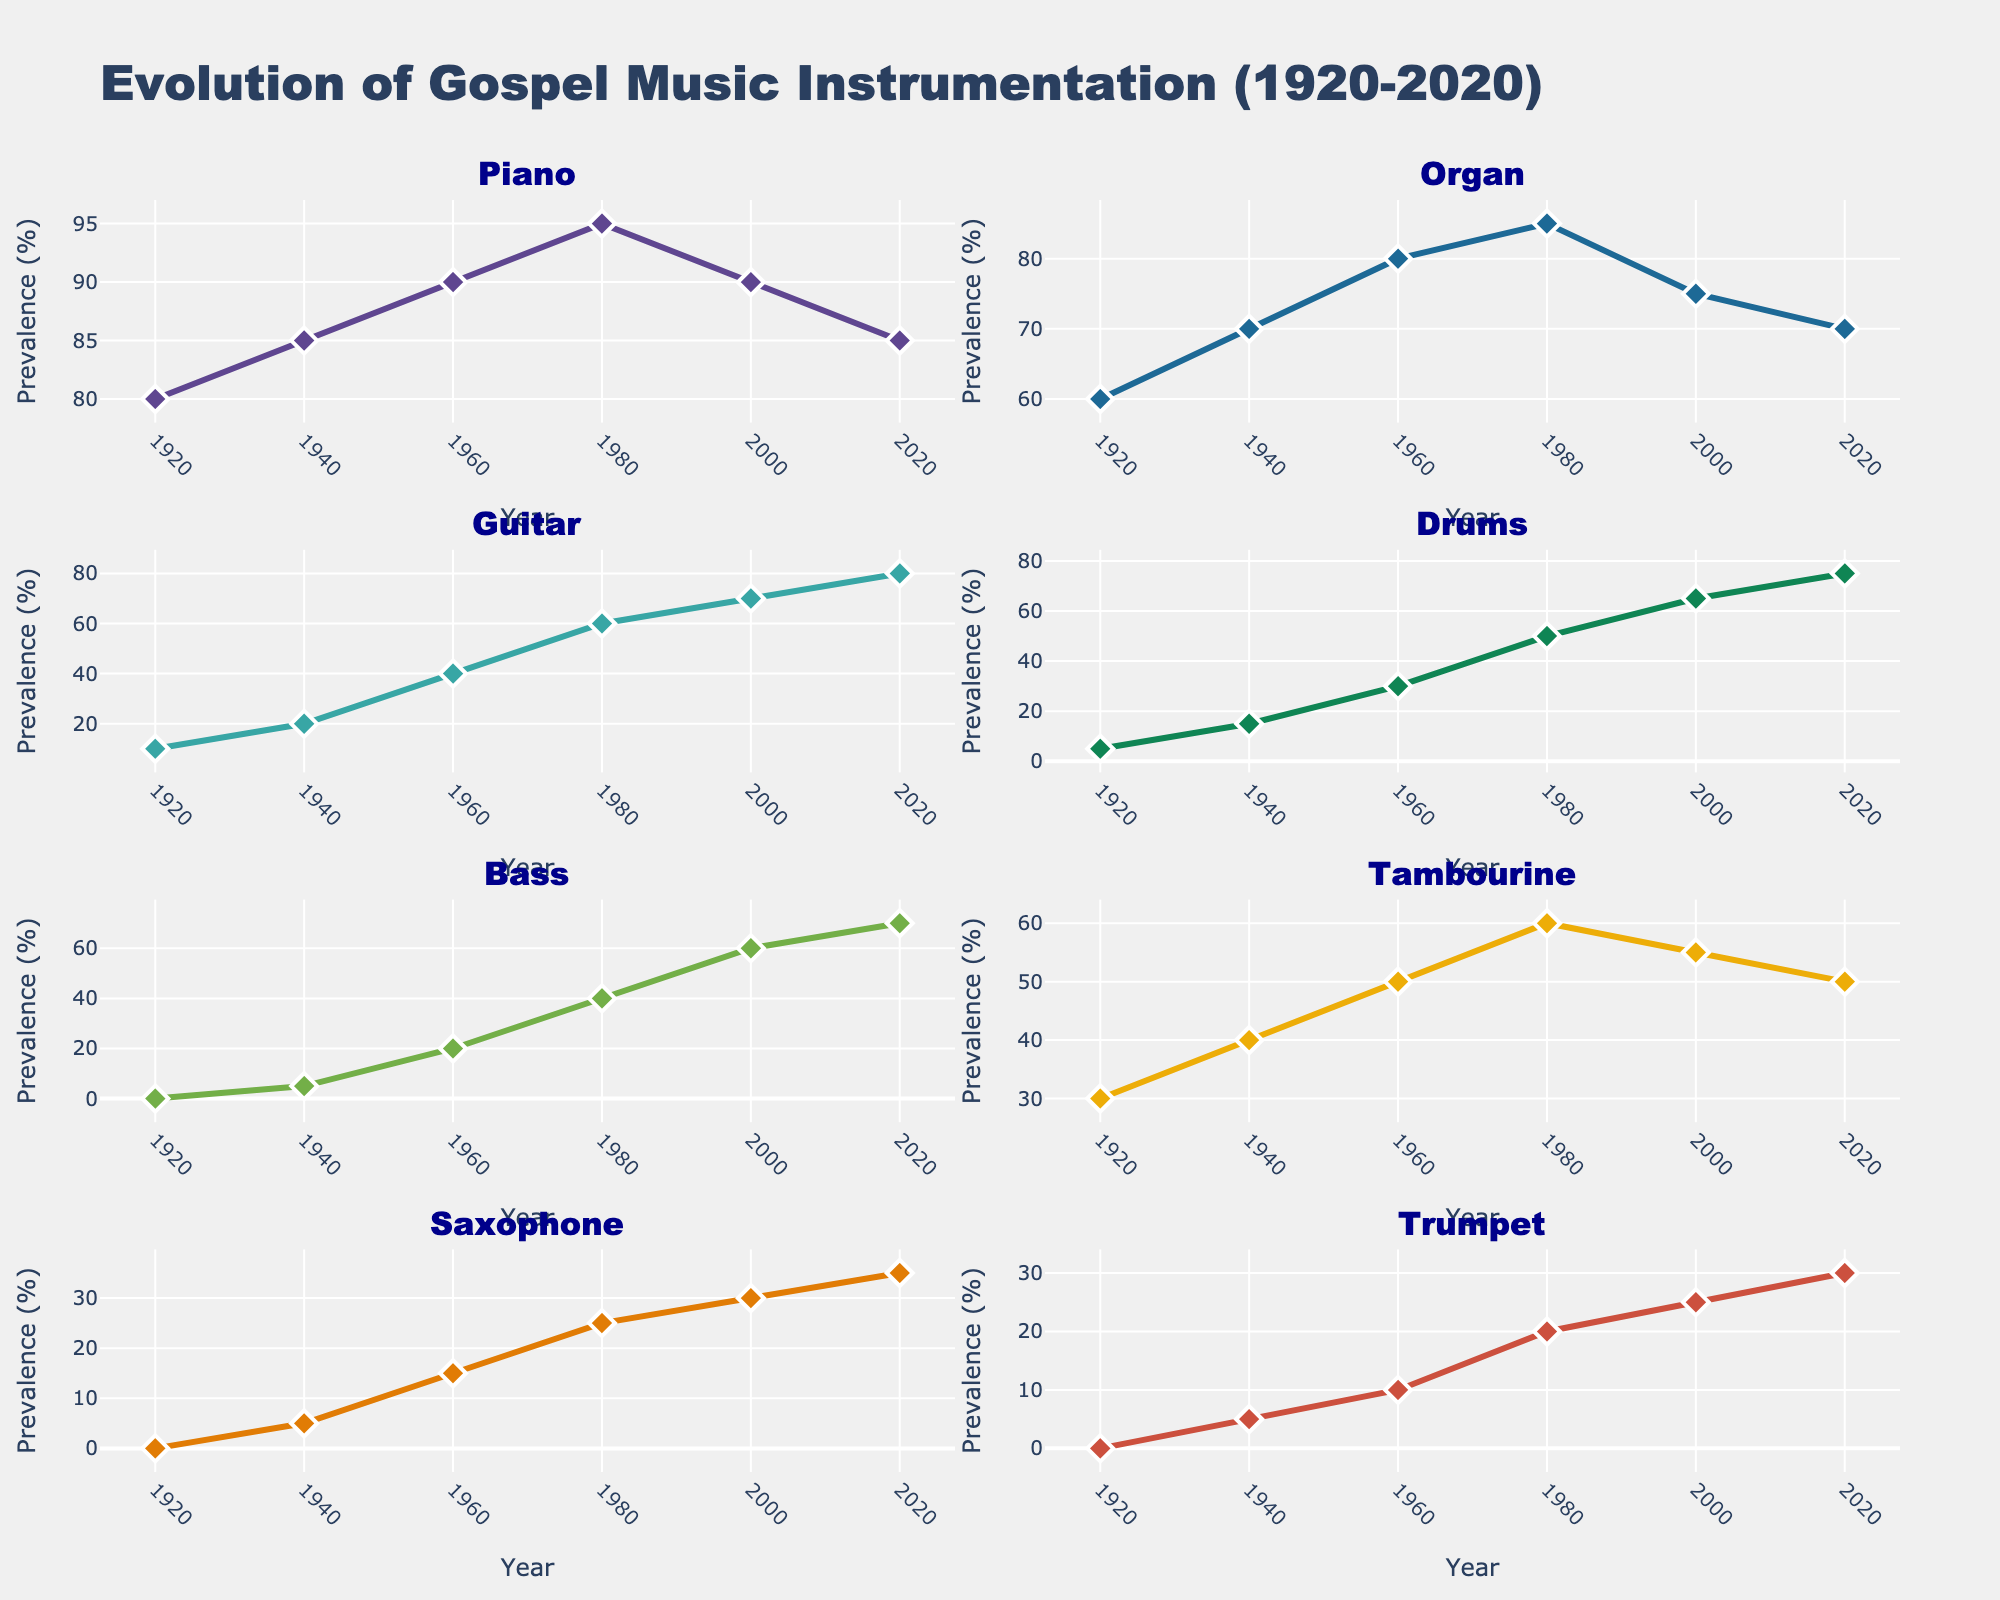What's the title of this set of plots? The title can be identified at the top of the figure. It reads "Montana Hunting Statistics (2010-2020)".
Answer: Montana Hunting Statistics (2010-2020) Which year had the highest number of hunting licenses issued? By looking at the bar plot in the "Hunting Licenses Issued" subplot, the tallest bar represents the maximum value. This occurs in 2012.
Answer: 2012 How did the deer population change from 2010 to 2020? Refer to the "Deer and Elk Population" subplot. The line for deer population starts at 550,000 in 2010 and decreases to 490,000 by 2020.
Answer: Decreased What is the difference between deer and elk harvest in 2015? Identify the values for deer and elk harvest in 2015 from the "Deer and Elk Harvest" subplot. Subtract the elk harvest (25,500) from the deer harvest (113,000).
Answer: 87,500 Which year shows the closest population values for both deer and elk? Compare the lines for deer and elk population in the "Deer and Elk Population" subplot. The year 2010 shows the closest values.
Answer: 2010 In which year did the deer harvest peak? The highest point on the deer harvest line in the "Deer and Elk Harvest" subplot is in 2012.
Answer: 2012 Does the elk harvest show a trend similar to the elk population? Observe the trends of the lines in both subplots "Deer and Elk Population" and "Deer and Elk Harvest". Both lines steadily decrease over the years.
Answer: Yes Is there a correlation between deer population and deer harvest? Refer to the "Population vs Harvest" subplot. The scatter plot shows a positive correlation as deer population increases, deer harvest also increases.
Answer: Positive correlation Which species saw a more significant population decline from 2010 to 2020? In the "Deer and Elk Population" subplot, compare the endpoints of both deer and elk population lines. The deer population went from 550,000 to 490,000, while the elk population went from 150,000 to 138,000. The deer population saw a larger numerical decline.
Answer: Deer 